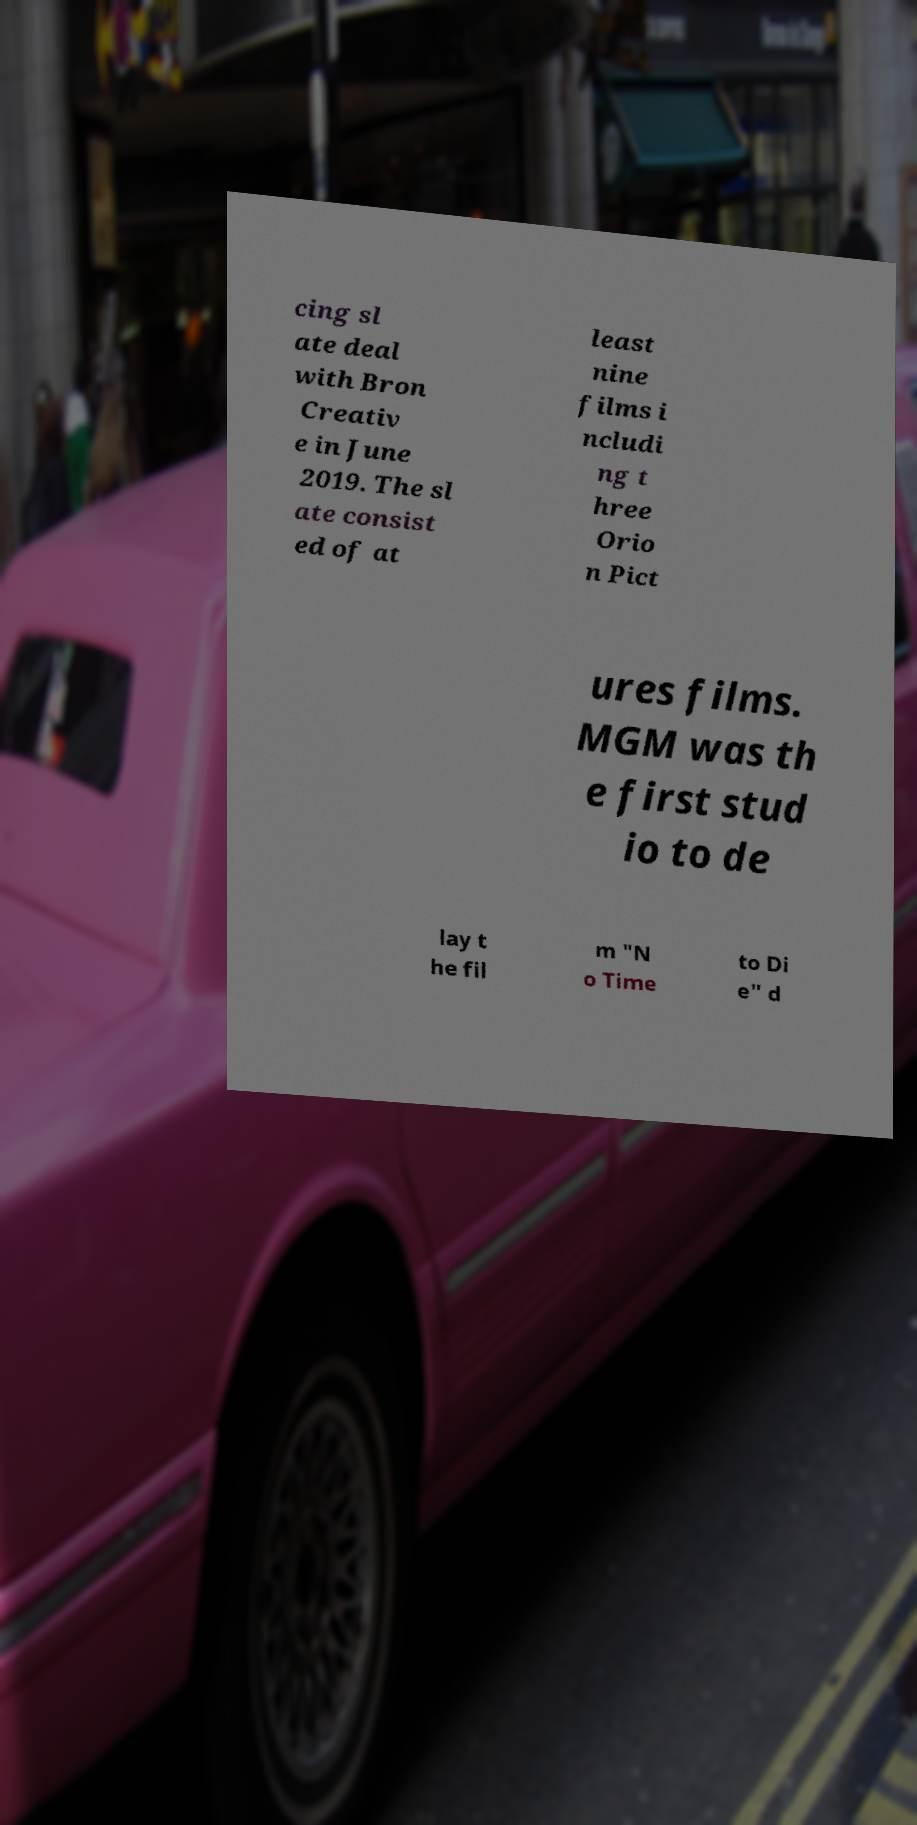There's text embedded in this image that I need extracted. Can you transcribe it verbatim? cing sl ate deal with Bron Creativ e in June 2019. The sl ate consist ed of at least nine films i ncludi ng t hree Orio n Pict ures films. MGM was th e first stud io to de lay t he fil m "N o Time to Di e" d 